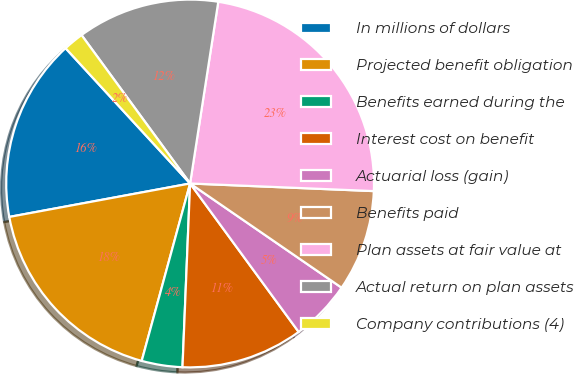Convert chart. <chart><loc_0><loc_0><loc_500><loc_500><pie_chart><fcel>In millions of dollars<fcel>Projected benefit obligation<fcel>Benefits earned during the<fcel>Interest cost on benefit<fcel>Actuarial loss (gain)<fcel>Benefits paid<fcel>Plan assets at fair value at<fcel>Actual return on plan assets<fcel>Company contributions (4)<nl><fcel>16.07%<fcel>17.85%<fcel>3.58%<fcel>10.71%<fcel>5.36%<fcel>8.93%<fcel>23.21%<fcel>12.5%<fcel>1.79%<nl></chart> 